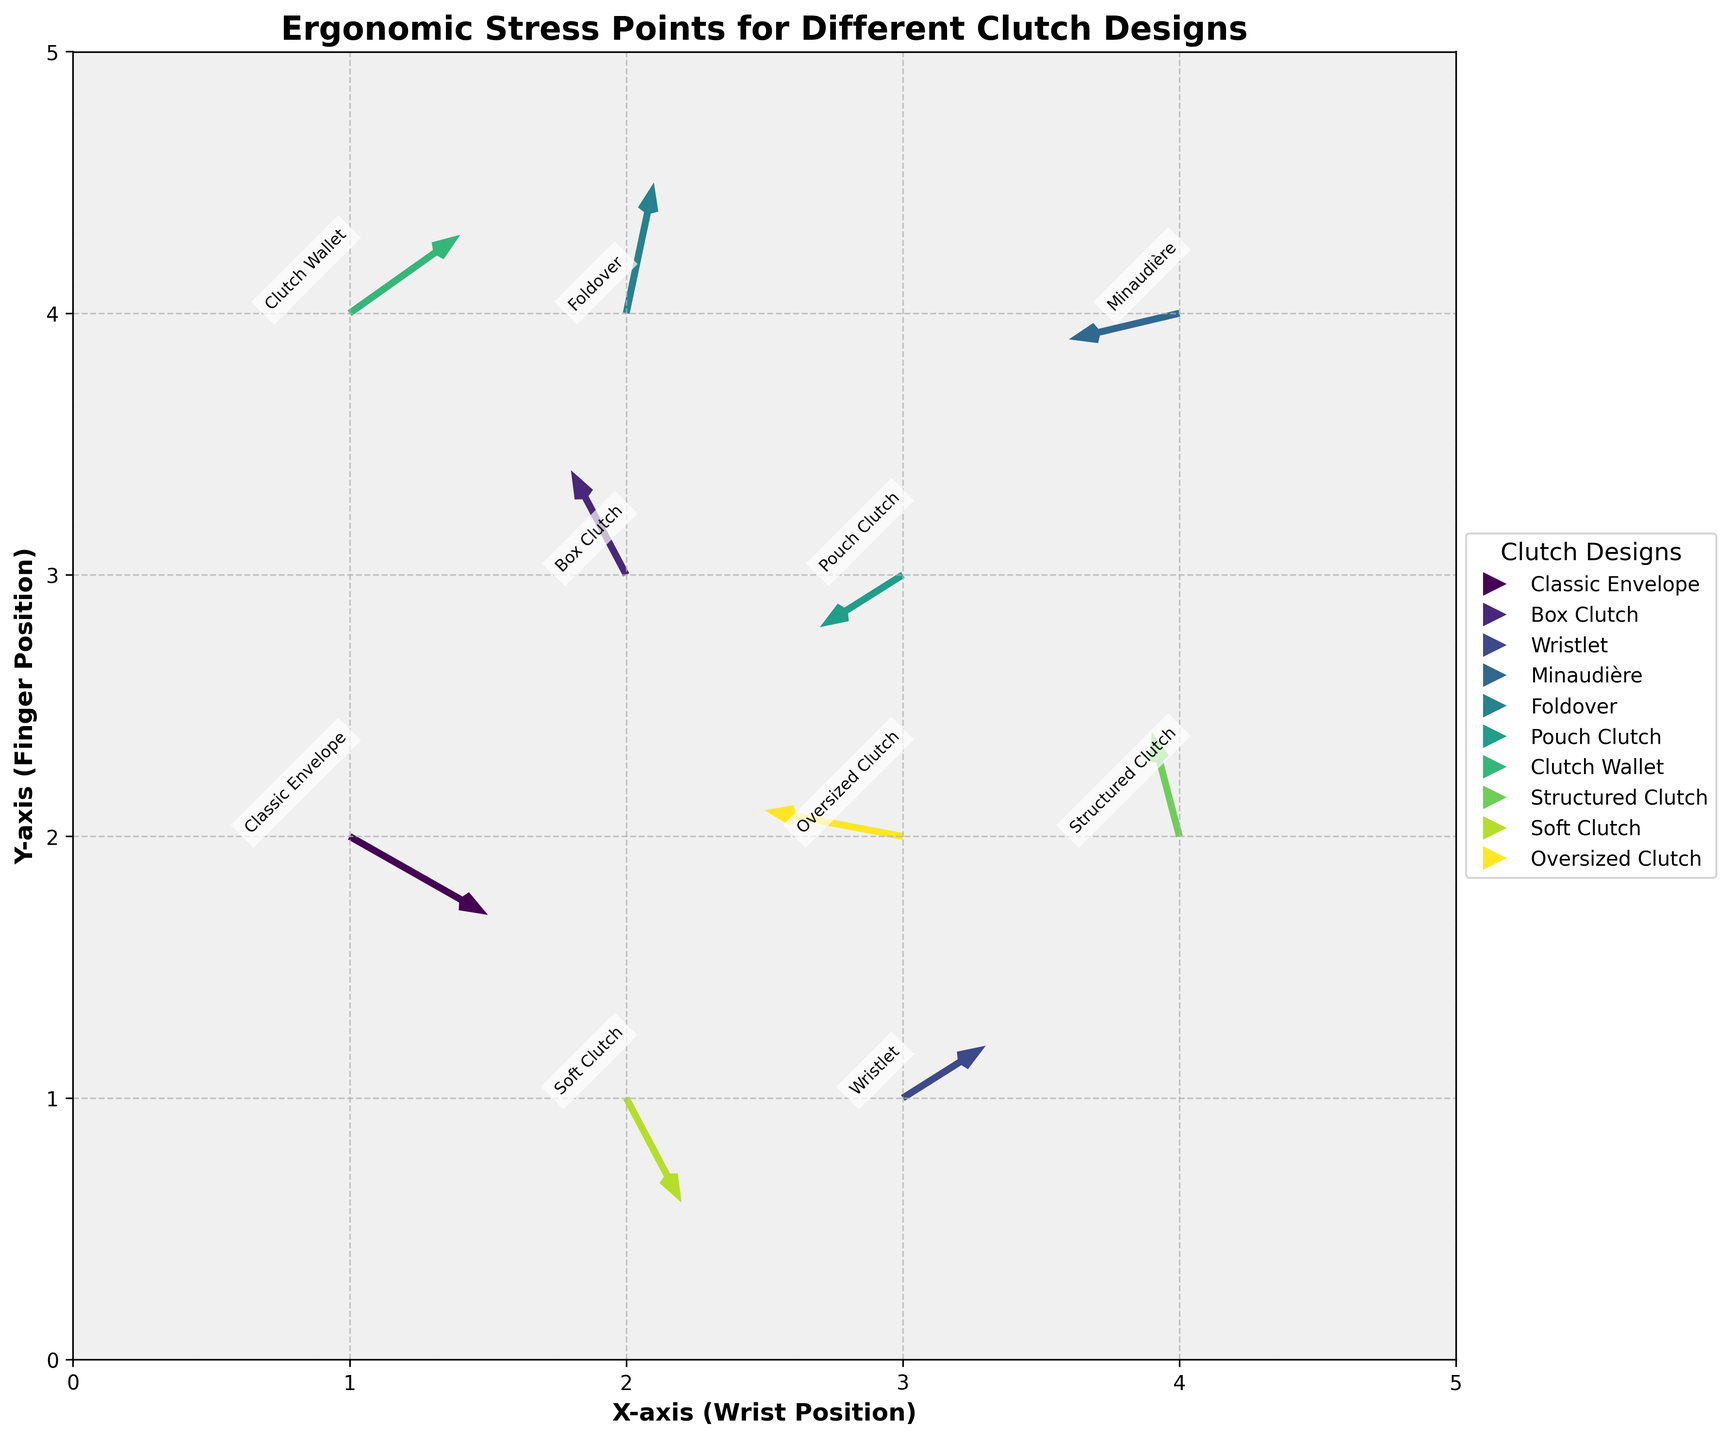What is the title of the plot? The title is typically found at the top of the plot and gives an idea of what the plot is about. In this case, the title of the plot reads "Ergonomic Stress Points for Different Clutch Designs."
Answer: Ergonomic Stress Points for Different Clutch Designs How many clutch designs are represented in the plot? To determine the number of unique clutch designs, one should count the labels next to each quiver arrow. The labels provided include Classic Envelope, Box Clutch, Wristlet, Minaudière, Foldover, Pouch Clutch, Clutch Wallet, Structured Clutch, Soft Clutch, and Oversized Clutch, summing up to 10 unique designs.
Answer: 10 Which clutch design has the arrow starting at (1, 2)? By observing the starting points of the arrows (x, y), we can find the arrow that starts at (1, 2). The label next to this arrow identifies the clutch design, which is "Classic Envelope" in this case.
Answer: Classic Envelope What is the direction of the arrow for the 'Soft Clutch' design? To find the direction of the arrow, we look at the components u and v of the vector. For the Soft Clutch, the coordinates are (2, 1) with components (0.2, -0.4), indicating a direction to the right (positive x component) and downward (negative y component).
Answer: Right and Down Which design exerts the most upward force on the fingers? An upward force is indicated by the highest positive value of the v component. Examining the data, the 'Foldover' design has a v value of 0.5, which is the highest.
Answer: Foldover Between the 'Wristlet' and 'Minaudière' designs, which one has a more negative x-component of force? The negative x-component of force is indicated by the u values. Comparing the Wristlet (-0.3) and Minaudière (-0.4), the 'Minaudière' has a more negative x-component.
Answer: Minaudière What is the total y-component of force (v) for all clutch designs? To find the total y-component, sum all the v values from the data: (-0.3) + 0.4 + 0.2 + (-0.1) + 0.5 + (-0.2) + 0.3 + 0.4 + (-0.4) + 0.1 = 0.9.
Answer: 0.9 Which clutch design's arrow points to the exact diagonal direction (45 degrees from starting point)? An arrow pointing exactly 45 degrees means the components u and v must be equal in magnitude but opposite in sign (indicating an equal right and upward or left and downward vector). No design matches exactly, but the 'Box Clutch' with (-0.2, 0.4) is close, pointing to a 63.43-degree angle from the horizontal.
Answer: None match exactly; Box Clutch is closest Which design cluster has the densest concentration of arrows? By visually examining the plot, the areas where arrows are most closely packed can be identified. The densest cluster appears around the coordinates (2, 3) to (3, 4), where Box Clutch, Pouch Clutch, Clutch Wallet, Foldover, and Structured Clutch are located.
Answer: Around (2, 3) to (3, 4) Is there any design showing a purely vertical movement of force? Purely vertical movement means the u component is 0, and there is only a v component. By observing the data, none of the designs have a u component exactly equal to 0.
Answer: No 